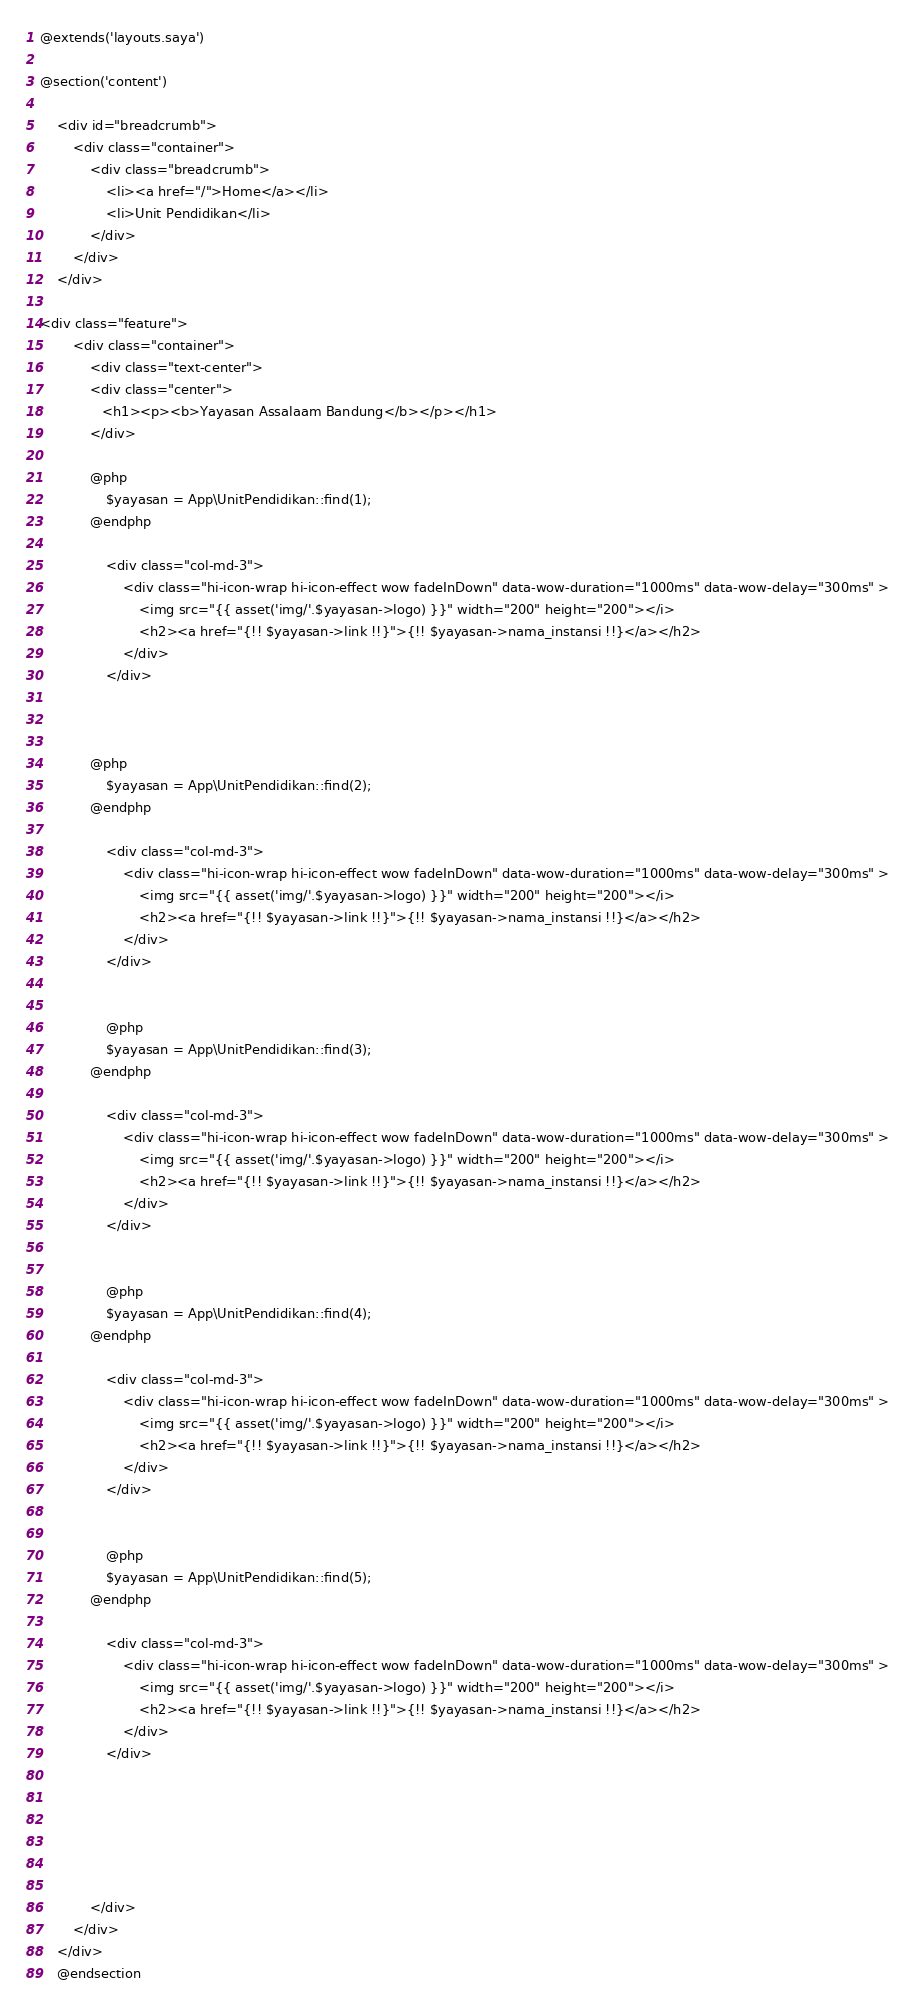<code> <loc_0><loc_0><loc_500><loc_500><_PHP_>@extends('layouts.saya')

@section('content')

	<div id="breadcrumb">
		<div class="container">	
			<div class="breadcrumb">							
				<li><a href="/">Home</a></li>
				<li>Unit Pendidikan</li>			
			</div>		
		</div>	
	</div>

<div class="feature">
		<div class="container">
			<div class="text-center">
			<div class="center">
               <h1><p><b>Yayasan Assalaam Bandung</b></p></h1>
            </div>

            @php
				$yayasan = App\UnitPendidikan::find(1);
			@endphp

				<div class="col-md-3">
					<div class="hi-icon-wrap hi-icon-effect wow fadeInDown" data-wow-duration="1000ms" data-wow-delay="300ms" >
						<img src="{{ asset('img/'.$yayasan->logo) }}" width="200" height="200"></i>	
						<h2><a href="{!! $yayasan->link !!}">{!! $yayasan->nama_instansi !!}</a></h2>
					</div>
				</div>

				
			
			@php
				$yayasan = App\UnitPendidikan::find(2);
			@endphp

				<div class="col-md-3">
					<div class="hi-icon-wrap hi-icon-effect wow fadeInDown" data-wow-duration="1000ms" data-wow-delay="300ms" >
						<img src="{{ asset('img/'.$yayasan->logo) }}" width="200" height="200"></i>	
						<h2><a href="{!! $yayasan->link !!}">{!! $yayasan->nama_instansi !!}</a></h2>
					</div>
				</div>
				

				@php
				$yayasan = App\UnitPendidikan::find(3);
			@endphp

				<div class="col-md-3">
					<div class="hi-icon-wrap hi-icon-effect wow fadeInDown" data-wow-duration="1000ms" data-wow-delay="300ms" >
						<img src="{{ asset('img/'.$yayasan->logo) }}" width="200" height="200"></i>	
						<h2><a href="{!! $yayasan->link !!}">{!! $yayasan->nama_instansi !!}</a></h2>
					</div>
				</div>
				

				@php
				$yayasan = App\UnitPendidikan::find(4);
			@endphp

				<div class="col-md-3">
					<div class="hi-icon-wrap hi-icon-effect wow fadeInDown" data-wow-duration="1000ms" data-wow-delay="300ms" >
						<img src="{{ asset('img/'.$yayasan->logo) }}" width="200" height="200"></i>	
						<h2><a href="{!! $yayasan->link !!}">{!! $yayasan->nama_instansi !!}</a></h2>
					</div>
				</div>
				

				@php
				$yayasan = App\UnitPendidikan::find(5);
			@endphp

				<div class="col-md-3">
					<div class="hi-icon-wrap hi-icon-effect wow fadeInDown" data-wow-duration="1000ms" data-wow-delay="300ms" >
						<img src="{{ asset('img/'.$yayasan->logo) }}" width="200" height="200"></i>	
						<h2><a href="{!! $yayasan->link !!}">{!! $yayasan->nama_instansi !!}</a></h2>
					</div>
				</div>
				




				
			</div>
		</div>
	</div>
	@endsection</code> 